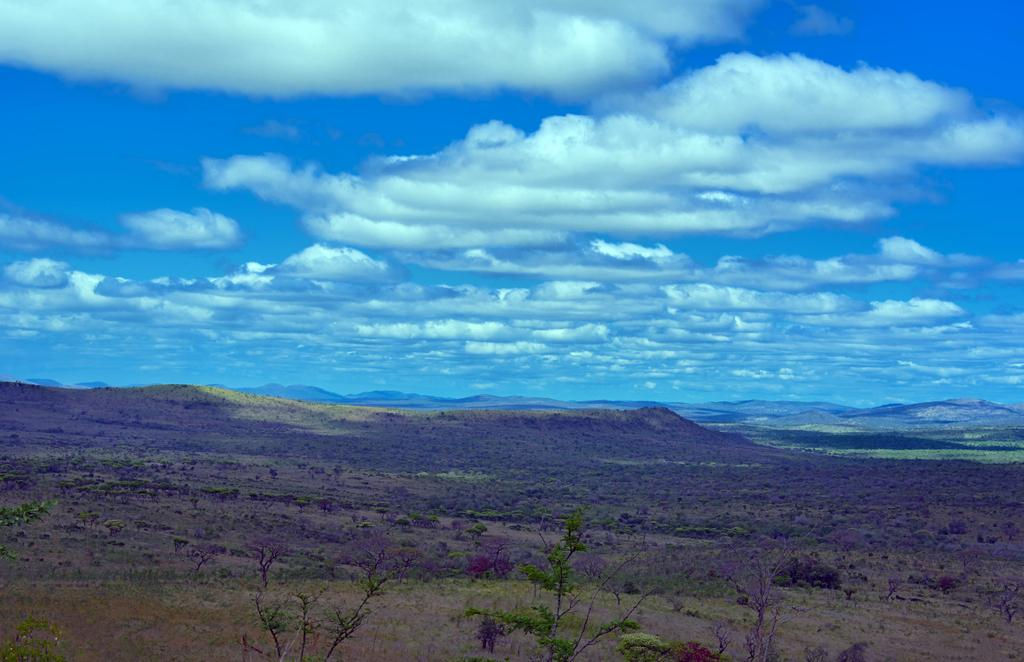What geographical feature is located in the center of the image? There are hills in the center of the image. What part of the natural environment is visible in the image? The sky is visible in the image. What type of vegetation can be seen at the bottom of the image? There are plants at the bottom of the image. What color is the crayon used to draw the hills in the image? There is no crayon present in the image; it is a photograph or illustration of actual hills. How does friction affect the movement of the plants at the bottom of the image? The question about friction is not relevant to the image, as it does not involve any moving objects or surfaces. 